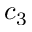<formula> <loc_0><loc_0><loc_500><loc_500>c _ { 3 }</formula> 